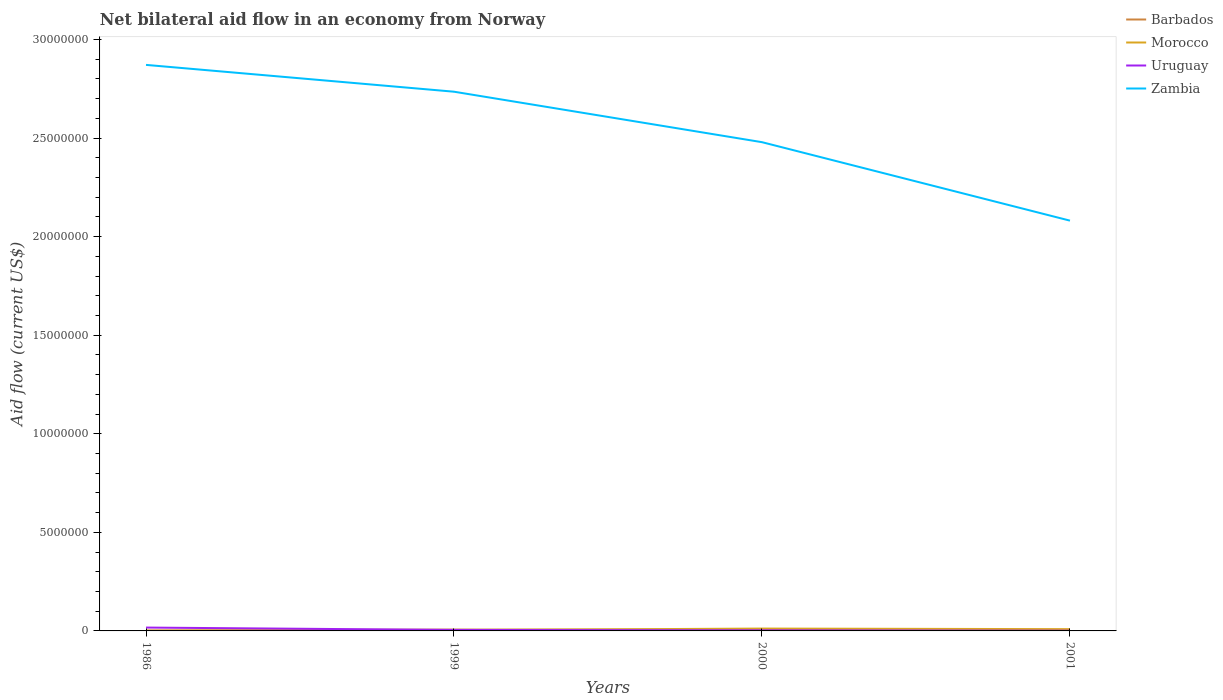Does the line corresponding to Uruguay intersect with the line corresponding to Zambia?
Offer a terse response. No. Is the number of lines equal to the number of legend labels?
Your answer should be very brief. No. Across all years, what is the maximum net bilateral aid flow in Uruguay?
Provide a short and direct response. 10000. What is the total net bilateral aid flow in Zambia in the graph?
Ensure brevity in your answer.  2.56e+06. What is the difference between the highest and the second highest net bilateral aid flow in Zambia?
Provide a short and direct response. 7.90e+06. What is the difference between the highest and the lowest net bilateral aid flow in Zambia?
Provide a succinct answer. 2. Is the net bilateral aid flow in Uruguay strictly greater than the net bilateral aid flow in Zambia over the years?
Keep it short and to the point. Yes. How many years are there in the graph?
Offer a very short reply. 4. Are the values on the major ticks of Y-axis written in scientific E-notation?
Offer a very short reply. No. How many legend labels are there?
Offer a very short reply. 4. How are the legend labels stacked?
Provide a short and direct response. Vertical. What is the title of the graph?
Your answer should be compact. Net bilateral aid flow in an economy from Norway. Does "Liberia" appear as one of the legend labels in the graph?
Your response must be concise. No. What is the label or title of the Y-axis?
Make the answer very short. Aid flow (current US$). What is the Aid flow (current US$) in Zambia in 1986?
Your response must be concise. 2.87e+07. What is the Aid flow (current US$) of Barbados in 1999?
Your response must be concise. 7.00e+04. What is the Aid flow (current US$) in Zambia in 1999?
Ensure brevity in your answer.  2.74e+07. What is the Aid flow (current US$) of Barbados in 2000?
Provide a short and direct response. 6.00e+04. What is the Aid flow (current US$) in Uruguay in 2000?
Offer a terse response. 3.00e+04. What is the Aid flow (current US$) of Zambia in 2000?
Ensure brevity in your answer.  2.48e+07. What is the Aid flow (current US$) of Barbados in 2001?
Offer a terse response. 0. What is the Aid flow (current US$) in Morocco in 2001?
Your answer should be very brief. 9.00e+04. What is the Aid flow (current US$) in Uruguay in 2001?
Provide a short and direct response. 10000. What is the Aid flow (current US$) in Zambia in 2001?
Your answer should be very brief. 2.08e+07. Across all years, what is the maximum Aid flow (current US$) in Morocco?
Your answer should be compact. 1.20e+05. Across all years, what is the maximum Aid flow (current US$) in Zambia?
Give a very brief answer. 2.87e+07. Across all years, what is the minimum Aid flow (current US$) in Morocco?
Keep it short and to the point. 10000. Across all years, what is the minimum Aid flow (current US$) of Zambia?
Your answer should be compact. 2.08e+07. What is the total Aid flow (current US$) of Morocco in the graph?
Offer a very short reply. 2.60e+05. What is the total Aid flow (current US$) of Zambia in the graph?
Offer a very short reply. 1.02e+08. What is the difference between the Aid flow (current US$) of Barbados in 1986 and that in 1999?
Your answer should be very brief. -5.00e+04. What is the difference between the Aid flow (current US$) of Uruguay in 1986 and that in 1999?
Your response must be concise. 1.20e+05. What is the difference between the Aid flow (current US$) of Zambia in 1986 and that in 1999?
Your answer should be compact. 1.36e+06. What is the difference between the Aid flow (current US$) of Morocco in 1986 and that in 2000?
Keep it short and to the point. -1.10e+05. What is the difference between the Aid flow (current US$) of Zambia in 1986 and that in 2000?
Keep it short and to the point. 3.92e+06. What is the difference between the Aid flow (current US$) in Morocco in 1986 and that in 2001?
Keep it short and to the point. -8.00e+04. What is the difference between the Aid flow (current US$) of Zambia in 1986 and that in 2001?
Provide a short and direct response. 7.90e+06. What is the difference between the Aid flow (current US$) of Barbados in 1999 and that in 2000?
Offer a very short reply. 10000. What is the difference between the Aid flow (current US$) in Zambia in 1999 and that in 2000?
Provide a succinct answer. 2.56e+06. What is the difference between the Aid flow (current US$) of Morocco in 1999 and that in 2001?
Ensure brevity in your answer.  -5.00e+04. What is the difference between the Aid flow (current US$) of Zambia in 1999 and that in 2001?
Offer a very short reply. 6.54e+06. What is the difference between the Aid flow (current US$) in Uruguay in 2000 and that in 2001?
Keep it short and to the point. 2.00e+04. What is the difference between the Aid flow (current US$) of Zambia in 2000 and that in 2001?
Give a very brief answer. 3.98e+06. What is the difference between the Aid flow (current US$) of Barbados in 1986 and the Aid flow (current US$) of Uruguay in 1999?
Your response must be concise. -3.00e+04. What is the difference between the Aid flow (current US$) of Barbados in 1986 and the Aid flow (current US$) of Zambia in 1999?
Your response must be concise. -2.73e+07. What is the difference between the Aid flow (current US$) of Morocco in 1986 and the Aid flow (current US$) of Zambia in 1999?
Offer a terse response. -2.73e+07. What is the difference between the Aid flow (current US$) in Uruguay in 1986 and the Aid flow (current US$) in Zambia in 1999?
Your answer should be very brief. -2.72e+07. What is the difference between the Aid flow (current US$) in Barbados in 1986 and the Aid flow (current US$) in Morocco in 2000?
Keep it short and to the point. -1.00e+05. What is the difference between the Aid flow (current US$) in Barbados in 1986 and the Aid flow (current US$) in Zambia in 2000?
Give a very brief answer. -2.48e+07. What is the difference between the Aid flow (current US$) in Morocco in 1986 and the Aid flow (current US$) in Zambia in 2000?
Give a very brief answer. -2.48e+07. What is the difference between the Aid flow (current US$) of Uruguay in 1986 and the Aid flow (current US$) of Zambia in 2000?
Your response must be concise. -2.46e+07. What is the difference between the Aid flow (current US$) of Barbados in 1986 and the Aid flow (current US$) of Morocco in 2001?
Provide a short and direct response. -7.00e+04. What is the difference between the Aid flow (current US$) of Barbados in 1986 and the Aid flow (current US$) of Uruguay in 2001?
Offer a very short reply. 10000. What is the difference between the Aid flow (current US$) of Barbados in 1986 and the Aid flow (current US$) of Zambia in 2001?
Make the answer very short. -2.08e+07. What is the difference between the Aid flow (current US$) in Morocco in 1986 and the Aid flow (current US$) in Uruguay in 2001?
Provide a short and direct response. 0. What is the difference between the Aid flow (current US$) of Morocco in 1986 and the Aid flow (current US$) of Zambia in 2001?
Ensure brevity in your answer.  -2.08e+07. What is the difference between the Aid flow (current US$) of Uruguay in 1986 and the Aid flow (current US$) of Zambia in 2001?
Provide a short and direct response. -2.06e+07. What is the difference between the Aid flow (current US$) in Barbados in 1999 and the Aid flow (current US$) in Morocco in 2000?
Keep it short and to the point. -5.00e+04. What is the difference between the Aid flow (current US$) in Barbados in 1999 and the Aid flow (current US$) in Zambia in 2000?
Keep it short and to the point. -2.47e+07. What is the difference between the Aid flow (current US$) in Morocco in 1999 and the Aid flow (current US$) in Uruguay in 2000?
Keep it short and to the point. 10000. What is the difference between the Aid flow (current US$) in Morocco in 1999 and the Aid flow (current US$) in Zambia in 2000?
Offer a very short reply. -2.48e+07. What is the difference between the Aid flow (current US$) in Uruguay in 1999 and the Aid flow (current US$) in Zambia in 2000?
Your answer should be very brief. -2.47e+07. What is the difference between the Aid flow (current US$) of Barbados in 1999 and the Aid flow (current US$) of Uruguay in 2001?
Provide a succinct answer. 6.00e+04. What is the difference between the Aid flow (current US$) of Barbados in 1999 and the Aid flow (current US$) of Zambia in 2001?
Give a very brief answer. -2.07e+07. What is the difference between the Aid flow (current US$) of Morocco in 1999 and the Aid flow (current US$) of Zambia in 2001?
Give a very brief answer. -2.08e+07. What is the difference between the Aid flow (current US$) in Uruguay in 1999 and the Aid flow (current US$) in Zambia in 2001?
Your answer should be compact. -2.08e+07. What is the difference between the Aid flow (current US$) in Barbados in 2000 and the Aid flow (current US$) in Morocco in 2001?
Provide a short and direct response. -3.00e+04. What is the difference between the Aid flow (current US$) of Barbados in 2000 and the Aid flow (current US$) of Zambia in 2001?
Offer a very short reply. -2.08e+07. What is the difference between the Aid flow (current US$) in Morocco in 2000 and the Aid flow (current US$) in Zambia in 2001?
Offer a very short reply. -2.07e+07. What is the difference between the Aid flow (current US$) in Uruguay in 2000 and the Aid flow (current US$) in Zambia in 2001?
Provide a short and direct response. -2.08e+07. What is the average Aid flow (current US$) of Barbados per year?
Ensure brevity in your answer.  3.75e+04. What is the average Aid flow (current US$) of Morocco per year?
Your response must be concise. 6.50e+04. What is the average Aid flow (current US$) of Uruguay per year?
Keep it short and to the point. 6.50e+04. What is the average Aid flow (current US$) of Zambia per year?
Your response must be concise. 2.54e+07. In the year 1986, what is the difference between the Aid flow (current US$) in Barbados and Aid flow (current US$) in Morocco?
Offer a terse response. 10000. In the year 1986, what is the difference between the Aid flow (current US$) of Barbados and Aid flow (current US$) of Uruguay?
Keep it short and to the point. -1.50e+05. In the year 1986, what is the difference between the Aid flow (current US$) in Barbados and Aid flow (current US$) in Zambia?
Make the answer very short. -2.87e+07. In the year 1986, what is the difference between the Aid flow (current US$) in Morocco and Aid flow (current US$) in Uruguay?
Offer a terse response. -1.60e+05. In the year 1986, what is the difference between the Aid flow (current US$) in Morocco and Aid flow (current US$) in Zambia?
Keep it short and to the point. -2.87e+07. In the year 1986, what is the difference between the Aid flow (current US$) in Uruguay and Aid flow (current US$) in Zambia?
Your answer should be very brief. -2.85e+07. In the year 1999, what is the difference between the Aid flow (current US$) of Barbados and Aid flow (current US$) of Morocco?
Offer a very short reply. 3.00e+04. In the year 1999, what is the difference between the Aid flow (current US$) in Barbados and Aid flow (current US$) in Uruguay?
Offer a very short reply. 2.00e+04. In the year 1999, what is the difference between the Aid flow (current US$) of Barbados and Aid flow (current US$) of Zambia?
Ensure brevity in your answer.  -2.73e+07. In the year 1999, what is the difference between the Aid flow (current US$) of Morocco and Aid flow (current US$) of Zambia?
Ensure brevity in your answer.  -2.73e+07. In the year 1999, what is the difference between the Aid flow (current US$) in Uruguay and Aid flow (current US$) in Zambia?
Give a very brief answer. -2.73e+07. In the year 2000, what is the difference between the Aid flow (current US$) of Barbados and Aid flow (current US$) of Morocco?
Provide a succinct answer. -6.00e+04. In the year 2000, what is the difference between the Aid flow (current US$) of Barbados and Aid flow (current US$) of Zambia?
Your answer should be very brief. -2.47e+07. In the year 2000, what is the difference between the Aid flow (current US$) of Morocco and Aid flow (current US$) of Uruguay?
Offer a terse response. 9.00e+04. In the year 2000, what is the difference between the Aid flow (current US$) of Morocco and Aid flow (current US$) of Zambia?
Make the answer very short. -2.47e+07. In the year 2000, what is the difference between the Aid flow (current US$) of Uruguay and Aid flow (current US$) of Zambia?
Make the answer very short. -2.48e+07. In the year 2001, what is the difference between the Aid flow (current US$) in Morocco and Aid flow (current US$) in Zambia?
Provide a short and direct response. -2.07e+07. In the year 2001, what is the difference between the Aid flow (current US$) in Uruguay and Aid flow (current US$) in Zambia?
Provide a short and direct response. -2.08e+07. What is the ratio of the Aid flow (current US$) in Barbados in 1986 to that in 1999?
Offer a very short reply. 0.29. What is the ratio of the Aid flow (current US$) in Uruguay in 1986 to that in 1999?
Give a very brief answer. 3.4. What is the ratio of the Aid flow (current US$) of Zambia in 1986 to that in 1999?
Give a very brief answer. 1.05. What is the ratio of the Aid flow (current US$) in Morocco in 1986 to that in 2000?
Give a very brief answer. 0.08. What is the ratio of the Aid flow (current US$) of Uruguay in 1986 to that in 2000?
Provide a succinct answer. 5.67. What is the ratio of the Aid flow (current US$) in Zambia in 1986 to that in 2000?
Offer a very short reply. 1.16. What is the ratio of the Aid flow (current US$) in Morocco in 1986 to that in 2001?
Provide a succinct answer. 0.11. What is the ratio of the Aid flow (current US$) in Uruguay in 1986 to that in 2001?
Offer a very short reply. 17. What is the ratio of the Aid flow (current US$) of Zambia in 1986 to that in 2001?
Your answer should be very brief. 1.38. What is the ratio of the Aid flow (current US$) in Barbados in 1999 to that in 2000?
Your answer should be very brief. 1.17. What is the ratio of the Aid flow (current US$) of Morocco in 1999 to that in 2000?
Your answer should be compact. 0.33. What is the ratio of the Aid flow (current US$) of Zambia in 1999 to that in 2000?
Offer a very short reply. 1.1. What is the ratio of the Aid flow (current US$) in Morocco in 1999 to that in 2001?
Your answer should be very brief. 0.44. What is the ratio of the Aid flow (current US$) of Uruguay in 1999 to that in 2001?
Provide a succinct answer. 5. What is the ratio of the Aid flow (current US$) in Zambia in 1999 to that in 2001?
Make the answer very short. 1.31. What is the ratio of the Aid flow (current US$) of Zambia in 2000 to that in 2001?
Give a very brief answer. 1.19. What is the difference between the highest and the second highest Aid flow (current US$) in Morocco?
Provide a succinct answer. 3.00e+04. What is the difference between the highest and the second highest Aid flow (current US$) of Uruguay?
Provide a succinct answer. 1.20e+05. What is the difference between the highest and the second highest Aid flow (current US$) of Zambia?
Your answer should be very brief. 1.36e+06. What is the difference between the highest and the lowest Aid flow (current US$) of Barbados?
Make the answer very short. 7.00e+04. What is the difference between the highest and the lowest Aid flow (current US$) in Morocco?
Your response must be concise. 1.10e+05. What is the difference between the highest and the lowest Aid flow (current US$) of Uruguay?
Ensure brevity in your answer.  1.60e+05. What is the difference between the highest and the lowest Aid flow (current US$) in Zambia?
Your answer should be compact. 7.90e+06. 